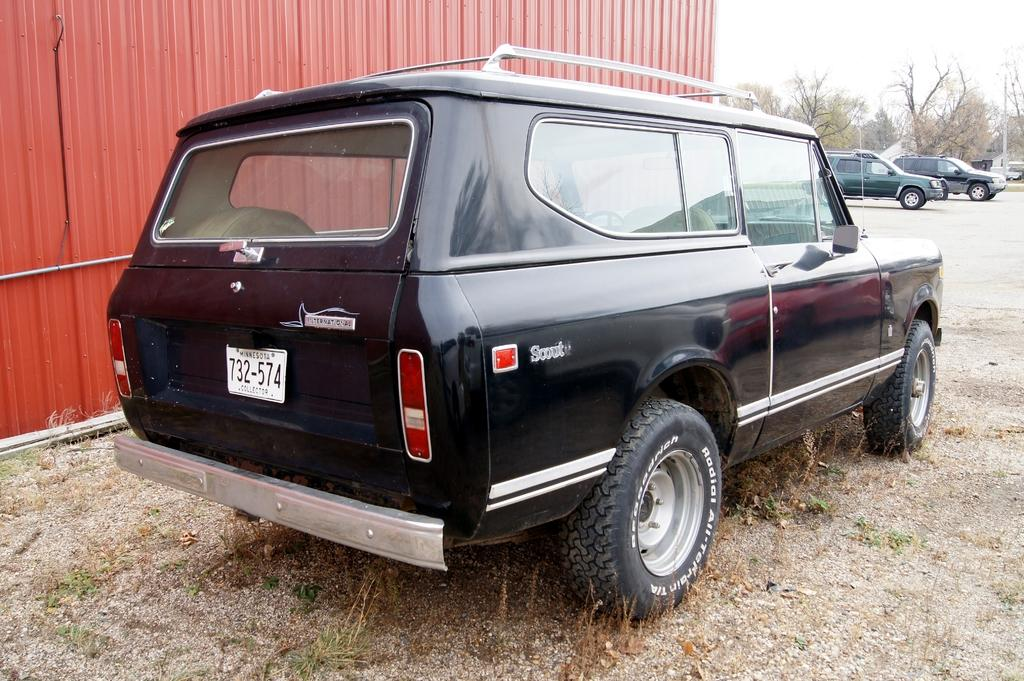What is the main subject in the foreground of the image? There is a car in the foreground of the image. What can be seen in the background of the image? In the background of the image, there is a container, cars, trees, and poles. What type of vegetation is visible at the bottom of the image? Grass is visible at the bottom of the image. What caption is written on the container in the background of the image? There is no caption visible on the container in the image. What is the mass of the car in the foreground of the image? The mass of the car cannot be determined from the image alone. 